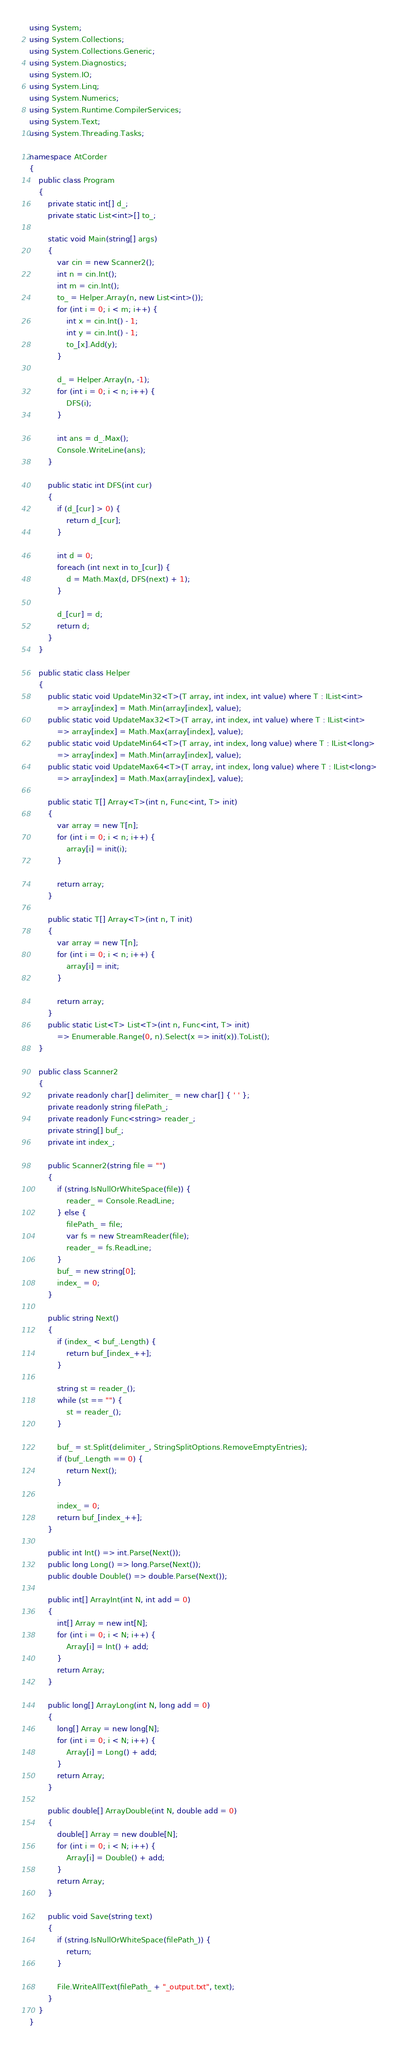<code> <loc_0><loc_0><loc_500><loc_500><_C#_>using System;
using System.Collections;
using System.Collections.Generic;
using System.Diagnostics;
using System.IO;
using System.Linq;
using System.Numerics;
using System.Runtime.CompilerServices;
using System.Text;
using System.Threading.Tasks;

namespace AtCorder
{
	public class Program
	{
		private static int[] d_;
		private static List<int>[] to_;

		static void Main(string[] args)
		{
			var cin = new Scanner2();
			int n = cin.Int();
			int m = cin.Int();
			to_ = Helper.Array(n, new List<int>());
			for (int i = 0; i < m; i++) {
				int x = cin.Int() - 1;
				int y = cin.Int() - 1;
				to_[x].Add(y);
			}

			d_ = Helper.Array(n, -1);
			for (int i = 0; i < n; i++) {
				DFS(i);
			}

			int ans = d_.Max();
			Console.WriteLine(ans);
		}

		public static int DFS(int cur)
		{
			if (d_[cur] > 0) {
				return d_[cur];
			}

			int d = 0;
			foreach (int next in to_[cur]) {
				d = Math.Max(d, DFS(next) + 1);
			}

			d_[cur] = d;
			return d;
		}
	}	

	public static class Helper
	{
		public static void UpdateMin32<T>(T array, int index, int value) where T : IList<int>
			=> array[index] = Math.Min(array[index], value);
		public static void UpdateMax32<T>(T array, int index, int value) where T : IList<int>
			=> array[index] = Math.Max(array[index], value);
		public static void UpdateMin64<T>(T array, int index, long value) where T : IList<long>
			=> array[index] = Math.Min(array[index], value);
		public static void UpdateMax64<T>(T array, int index, long value) where T : IList<long>
			=> array[index] = Math.Max(array[index], value);

		public static T[] Array<T>(int n, Func<int, T> init)
		{
			var array = new T[n];
			for (int i = 0; i < n; i++) {
				array[i] = init(i);
			}

			return array;
		}

		public static T[] Array<T>(int n, T init)
		{
			var array = new T[n];
			for (int i = 0; i < n; i++) {
				array[i] = init;
			}

			return array;
		}
		public static List<T> List<T>(int n, Func<int, T> init)
			=> Enumerable.Range(0, n).Select(x => init(x)).ToList();
	}

	public class Scanner2
	{
		private readonly char[] delimiter_ = new char[] { ' ' };
		private readonly string filePath_;
		private readonly Func<string> reader_;
		private string[] buf_;
		private int index_;

		public Scanner2(string file = "")
		{
			if (string.IsNullOrWhiteSpace(file)) {
				reader_ = Console.ReadLine;
			} else {
				filePath_ = file;
				var fs = new StreamReader(file);
				reader_ = fs.ReadLine;
			}
			buf_ = new string[0];
			index_ = 0;
		}

		public string Next()
		{
			if (index_ < buf_.Length) {
				return buf_[index_++];
			}

			string st = reader_();
			while (st == "") {
				st = reader_();
			}

			buf_ = st.Split(delimiter_, StringSplitOptions.RemoveEmptyEntries);
			if (buf_.Length == 0) {
				return Next();
			}

			index_ = 0;
			return buf_[index_++];
		}

		public int Int() => int.Parse(Next());
		public long Long() => long.Parse(Next());
		public double Double() => double.Parse(Next());

		public int[] ArrayInt(int N, int add = 0)
		{
			int[] Array = new int[N];
			for (int i = 0; i < N; i++) {
				Array[i] = Int() + add;
			}
			return Array;
		}

		public long[] ArrayLong(int N, long add = 0)
		{
			long[] Array = new long[N];
			for (int i = 0; i < N; i++) {
				Array[i] = Long() + add;
			}
			return Array;
		}

		public double[] ArrayDouble(int N, double add = 0)
		{
			double[] Array = new double[N];
			for (int i = 0; i < N; i++) {
				Array[i] = Double() + add;
			}
			return Array;
		}

		public void Save(string text)
		{
			if (string.IsNullOrWhiteSpace(filePath_)) {
				return;
			}

			File.WriteAllText(filePath_ + "_output.txt", text);
		}
	}
}</code> 